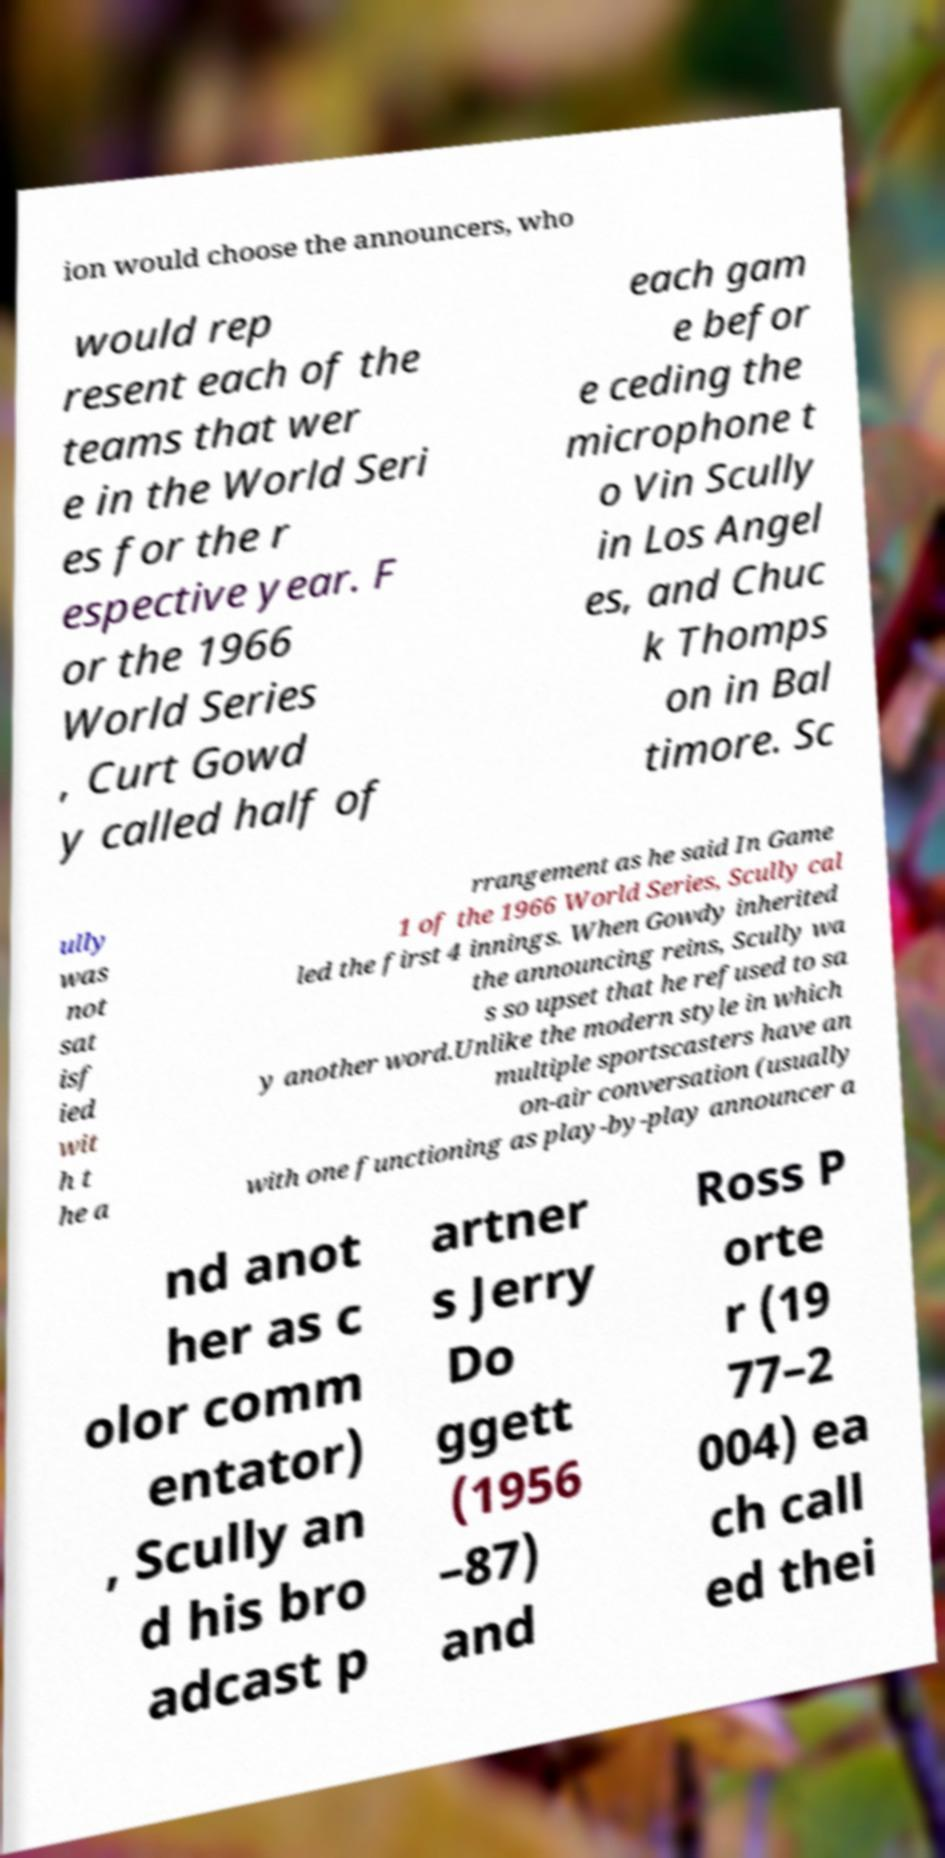Can you accurately transcribe the text from the provided image for me? ion would choose the announcers, who would rep resent each of the teams that wer e in the World Seri es for the r espective year. F or the 1966 World Series , Curt Gowd y called half of each gam e befor e ceding the microphone t o Vin Scully in Los Angel es, and Chuc k Thomps on in Bal timore. Sc ully was not sat isf ied wit h t he a rrangement as he said In Game 1 of the 1966 World Series, Scully cal led the first 4 innings. When Gowdy inherited the announcing reins, Scully wa s so upset that he refused to sa y another word.Unlike the modern style in which multiple sportscasters have an on-air conversation (usually with one functioning as play-by-play announcer a nd anot her as c olor comm entator) , Scully an d his bro adcast p artner s Jerry Do ggett (1956 –87) and Ross P orte r (19 77–2 004) ea ch call ed thei 